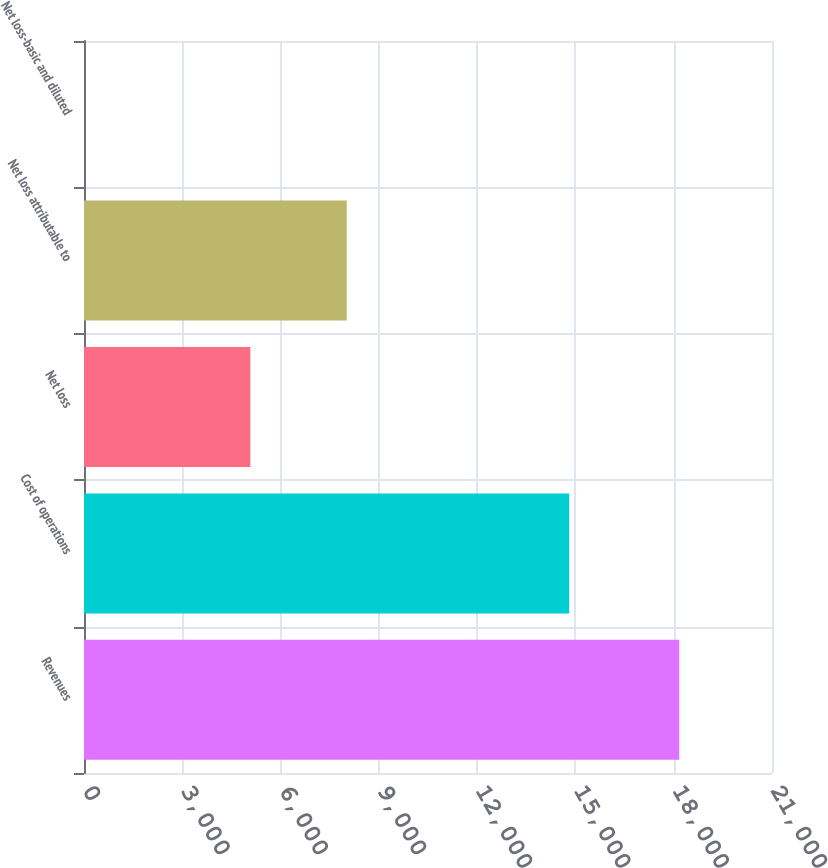<chart> <loc_0><loc_0><loc_500><loc_500><bar_chart><fcel>Revenues<fcel>Cost of operations<fcel>Net loss<fcel>Net loss attributable to<fcel>Net loss-basic and diluted<nl><fcel>18168<fcel>14808<fcel>5077<fcel>8020<fcel>0.53<nl></chart> 